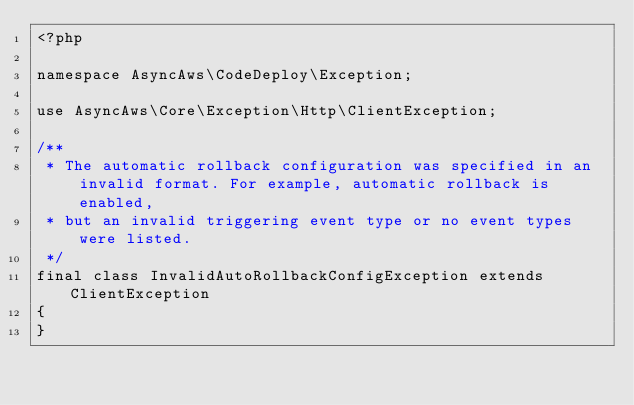Convert code to text. <code><loc_0><loc_0><loc_500><loc_500><_PHP_><?php

namespace AsyncAws\CodeDeploy\Exception;

use AsyncAws\Core\Exception\Http\ClientException;

/**
 * The automatic rollback configuration was specified in an invalid format. For example, automatic rollback is enabled,
 * but an invalid triggering event type or no event types were listed.
 */
final class InvalidAutoRollbackConfigException extends ClientException
{
}
</code> 